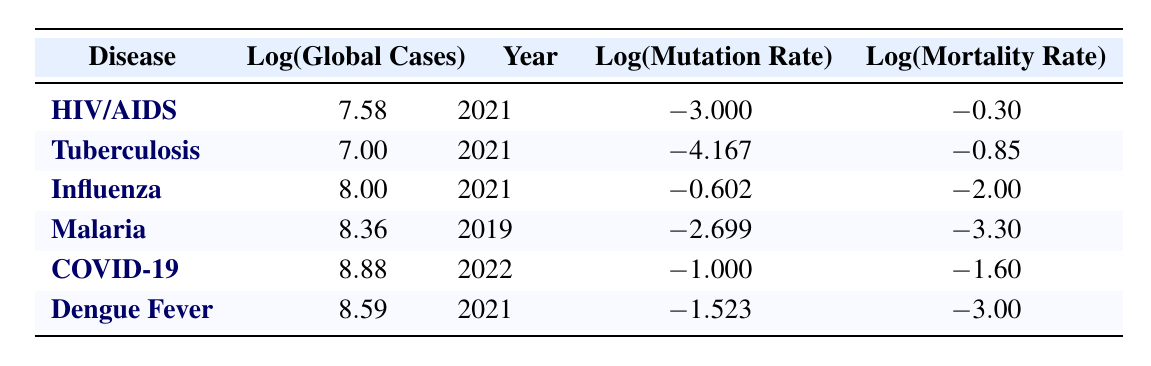What is the global case count for Influenza? The global case count for Influenza is found in the table under the "Log(Global Cases)" column for the row where the disease is Influenza. The value is 100000000.
Answer: 100000000 Which disease has the lowest mortality rate? To determine which disease has the lowest mortality rate, we can compare the "Log(Mortality Rate)" values in the table. The lowest value is associated with Malaria, which has a mortality rate of 0.0005.
Answer: Malaria What is the difference between the log values of global cases for COVID-19 and Tuberculosis? The log value for COVID-19 is 8.88 and for Tuberculosis is 7.00. The difference is calculated as 8.88 - 7.00 = 1.88.
Answer: 1.88 Is it true that Dengue Fever has a higher mutation rate per cycle than Tuberculosis? By examining the "Log(Mutation Rate)" for both diseases, Dengue Fever has a mutation rate of -1.523, while Tuberculosis has -4.167. Since -1.523 is greater than -4.167, Dengue Fever does indeed have a higher mutation rate.
Answer: Yes What is the average log value of mortality rates for all diseases listed in the table? First, we need to sum the log values of mortality rates for all diseases: -0.30 (HIV/AIDS) + -0.85 (Tuberculosis) + -2.00 (Influenza) + -3.30 (Malaria) + -1.60 (COVID-19) + -3.00 (Dengue Fever) = -11.05. Then, we divide by the number of diseases, which is 6, giving us an average of -11.05 / 6 = -1.84.
Answer: -1.84 Which disease has the highest global case count, and what is that count? The highest global case count can be found in the "Log(Global Cases)" column, where the value is highest for COVID-19 at 766000000.
Answer: COVID-19, 766000000 